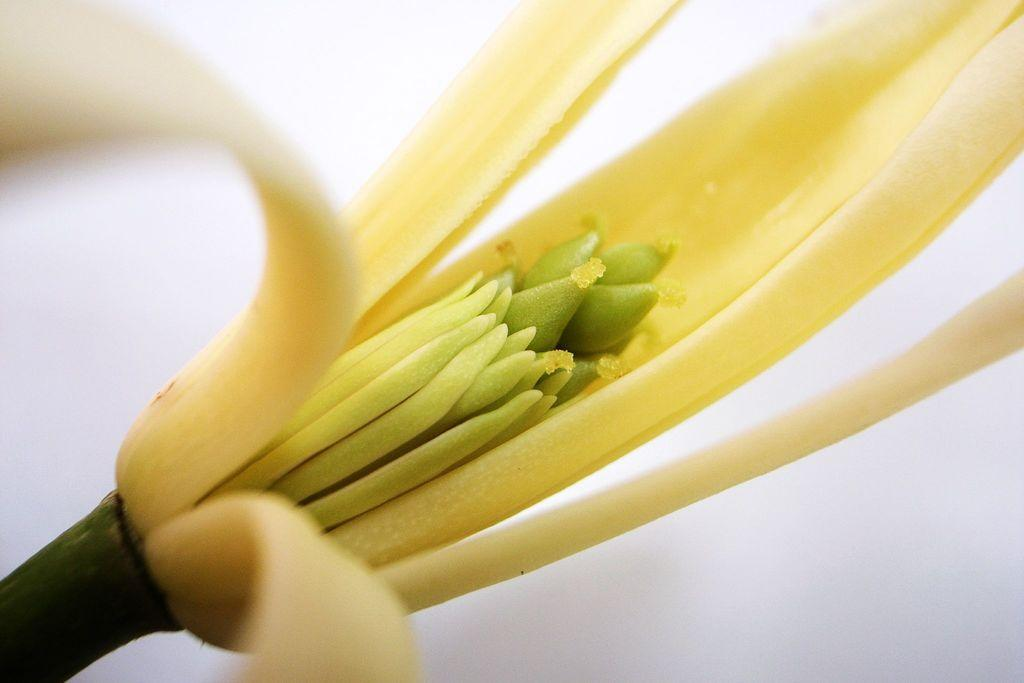What type of flower is visible in the image? There is a yellow flower in the image. How is the flower positioned in the image? The flower is on a stem. What can be observed about the background of the image? The background of the image is blurred. Can you tell me how many baseballs are visible in the image? There are no baseballs present in the image. Is there a lawyer visible in the image? There is no lawyer present in the image. 